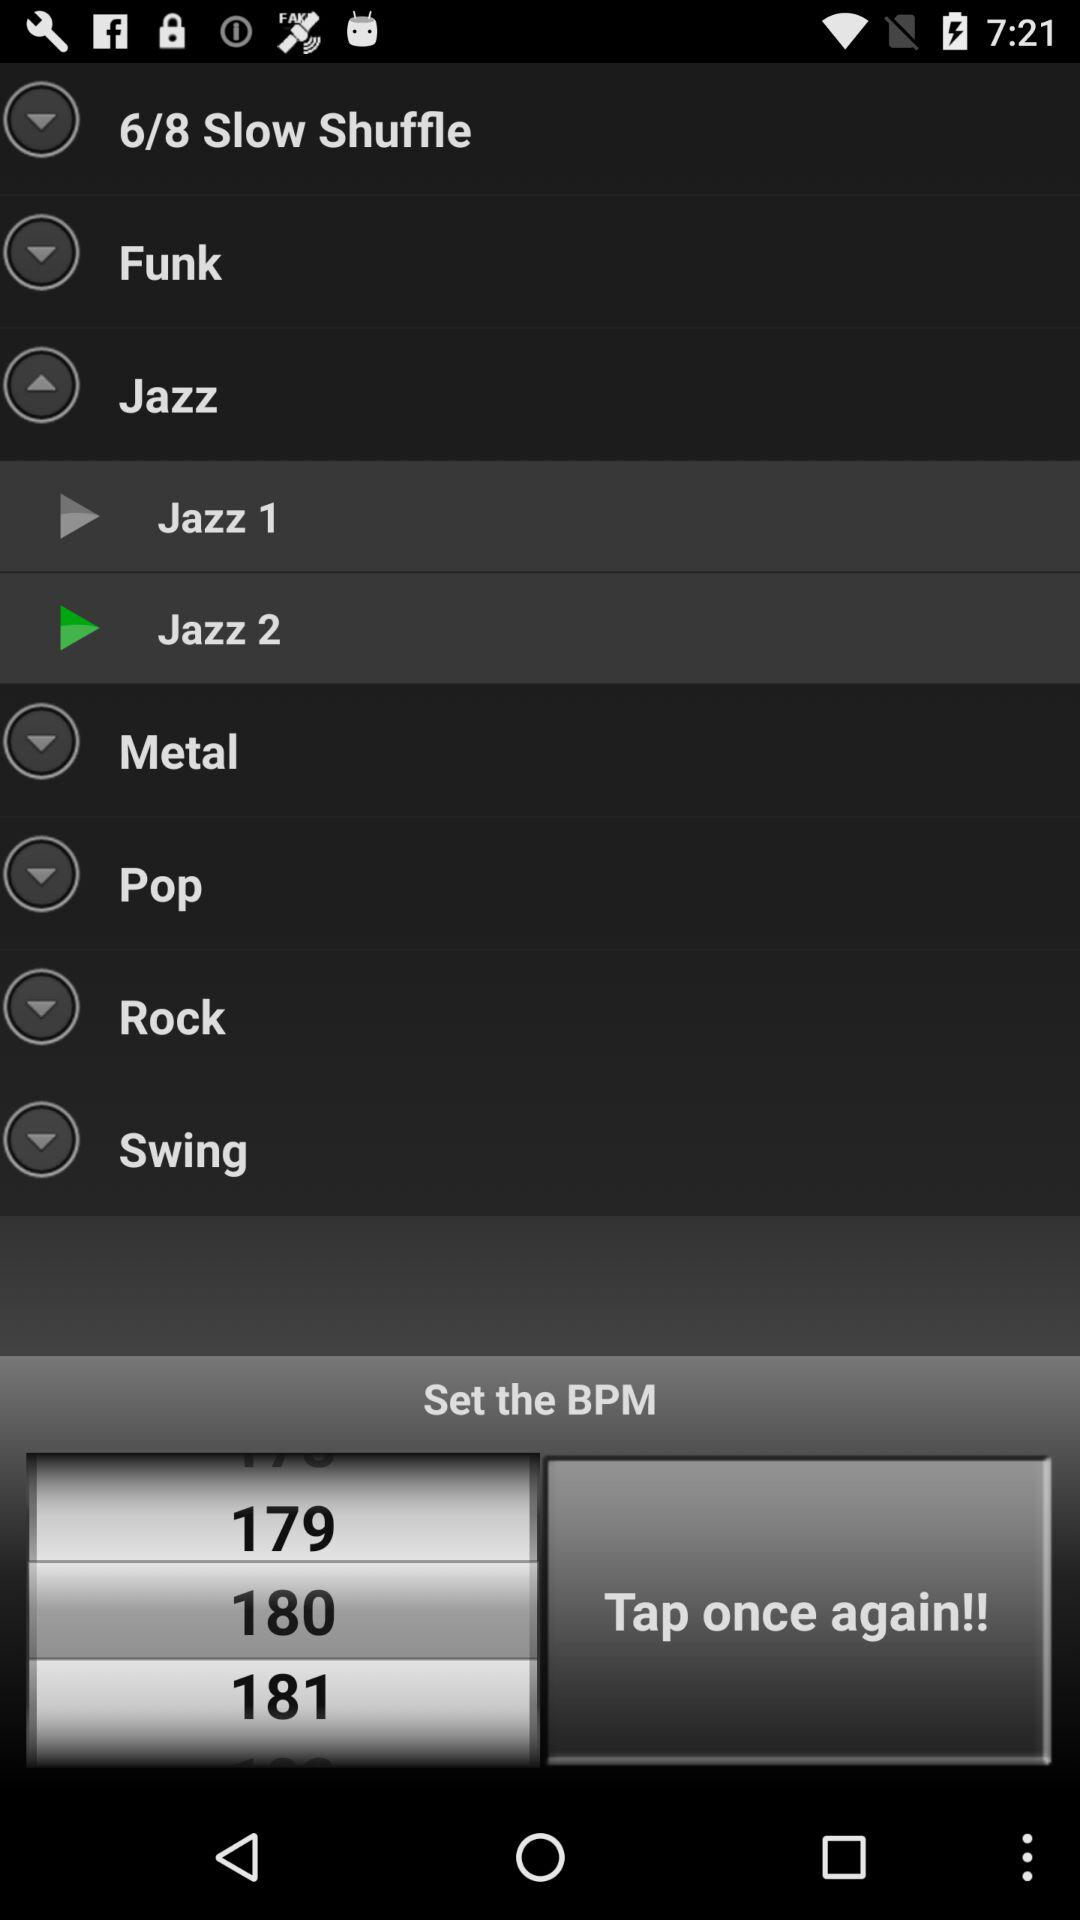What is the set BPM? The set BPM is 180. 